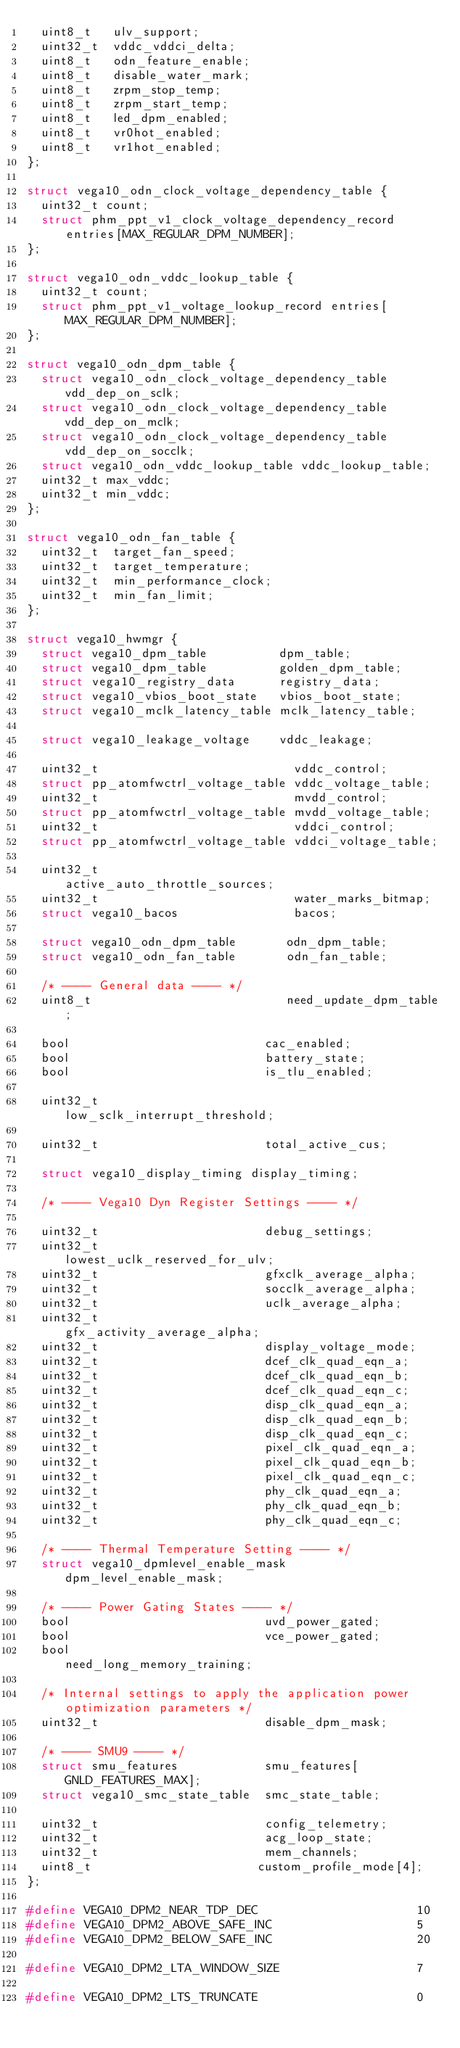Convert code to text. <code><loc_0><loc_0><loc_500><loc_500><_C_>	uint8_t   ulv_support;
	uint32_t  vddc_vddci_delta;
	uint8_t   odn_feature_enable;
	uint8_t   disable_water_mark;
	uint8_t   zrpm_stop_temp;
	uint8_t   zrpm_start_temp;
	uint8_t   led_dpm_enabled;
	uint8_t   vr0hot_enabled;
	uint8_t   vr1hot_enabled;
};

struct vega10_odn_clock_voltage_dependency_table {
	uint32_t count;
	struct phm_ppt_v1_clock_voltage_dependency_record entries[MAX_REGULAR_DPM_NUMBER];
};

struct vega10_odn_vddc_lookup_table {
	uint32_t count;
	struct phm_ppt_v1_voltage_lookup_record entries[MAX_REGULAR_DPM_NUMBER];
};

struct vega10_odn_dpm_table {
	struct vega10_odn_clock_voltage_dependency_table vdd_dep_on_sclk;
	struct vega10_odn_clock_voltage_dependency_table vdd_dep_on_mclk;
	struct vega10_odn_clock_voltage_dependency_table vdd_dep_on_socclk;
	struct vega10_odn_vddc_lookup_table vddc_lookup_table;
	uint32_t max_vddc;
	uint32_t min_vddc;
};

struct vega10_odn_fan_table {
	uint32_t	target_fan_speed;
	uint32_t	target_temperature;
	uint32_t	min_performance_clock;
	uint32_t	min_fan_limit;
};

struct vega10_hwmgr {
	struct vega10_dpm_table          dpm_table;
	struct vega10_dpm_table          golden_dpm_table;
	struct vega10_registry_data      registry_data;
	struct vega10_vbios_boot_state   vbios_boot_state;
	struct vega10_mclk_latency_table mclk_latency_table;

	struct vega10_leakage_voltage    vddc_leakage;

	uint32_t                           vddc_control;
	struct pp_atomfwctrl_voltage_table vddc_voltage_table;
	uint32_t                           mvdd_control;
	struct pp_atomfwctrl_voltage_table mvdd_voltage_table;
	uint32_t                           vddci_control;
	struct pp_atomfwctrl_voltage_table vddci_voltage_table;

	uint32_t                           active_auto_throttle_sources;
	uint32_t                           water_marks_bitmap;
	struct vega10_bacos                bacos;

	struct vega10_odn_dpm_table       odn_dpm_table;
	struct vega10_odn_fan_table       odn_fan_table;

	/* ---- General data ---- */
	uint8_t                           need_update_dpm_table;

	bool                           cac_enabled;
	bool                           battery_state;
	bool                           is_tlu_enabled;

	uint32_t                       low_sclk_interrupt_threshold;

	uint32_t                       total_active_cus;

	struct vega10_display_timing display_timing;

	/* ---- Vega10 Dyn Register Settings ---- */

	uint32_t                       debug_settings;
	uint32_t                       lowest_uclk_reserved_for_ulv;
	uint32_t                       gfxclk_average_alpha;
	uint32_t                       socclk_average_alpha;
	uint32_t                       uclk_average_alpha;
	uint32_t                       gfx_activity_average_alpha;
	uint32_t                       display_voltage_mode;
	uint32_t                       dcef_clk_quad_eqn_a;
	uint32_t                       dcef_clk_quad_eqn_b;
	uint32_t                       dcef_clk_quad_eqn_c;
	uint32_t                       disp_clk_quad_eqn_a;
	uint32_t                       disp_clk_quad_eqn_b;
	uint32_t                       disp_clk_quad_eqn_c;
	uint32_t                       pixel_clk_quad_eqn_a;
	uint32_t                       pixel_clk_quad_eqn_b;
	uint32_t                       pixel_clk_quad_eqn_c;
	uint32_t                       phy_clk_quad_eqn_a;
	uint32_t                       phy_clk_quad_eqn_b;
	uint32_t                       phy_clk_quad_eqn_c;

	/* ---- Thermal Temperature Setting ---- */
	struct vega10_dpmlevel_enable_mask     dpm_level_enable_mask;

	/* ---- Power Gating States ---- */
	bool                           uvd_power_gated;
	bool                           vce_power_gated;
	bool                           need_long_memory_training;

	/* Internal settings to apply the application power optimization parameters */
	uint32_t                       disable_dpm_mask;

	/* ---- SMU9 ---- */
	struct smu_features            smu_features[GNLD_FEATURES_MAX];
	struct vega10_smc_state_table  smc_state_table;

	uint32_t                       config_telemetry;
	uint32_t                       acg_loop_state;
	uint32_t                       mem_channels;
	uint8_t                       custom_profile_mode[4];
};

#define VEGA10_DPM2_NEAR_TDP_DEC                      10
#define VEGA10_DPM2_ABOVE_SAFE_INC                    5
#define VEGA10_DPM2_BELOW_SAFE_INC                    20

#define VEGA10_DPM2_LTA_WINDOW_SIZE                   7

#define VEGA10_DPM2_LTS_TRUNCATE                      0
</code> 